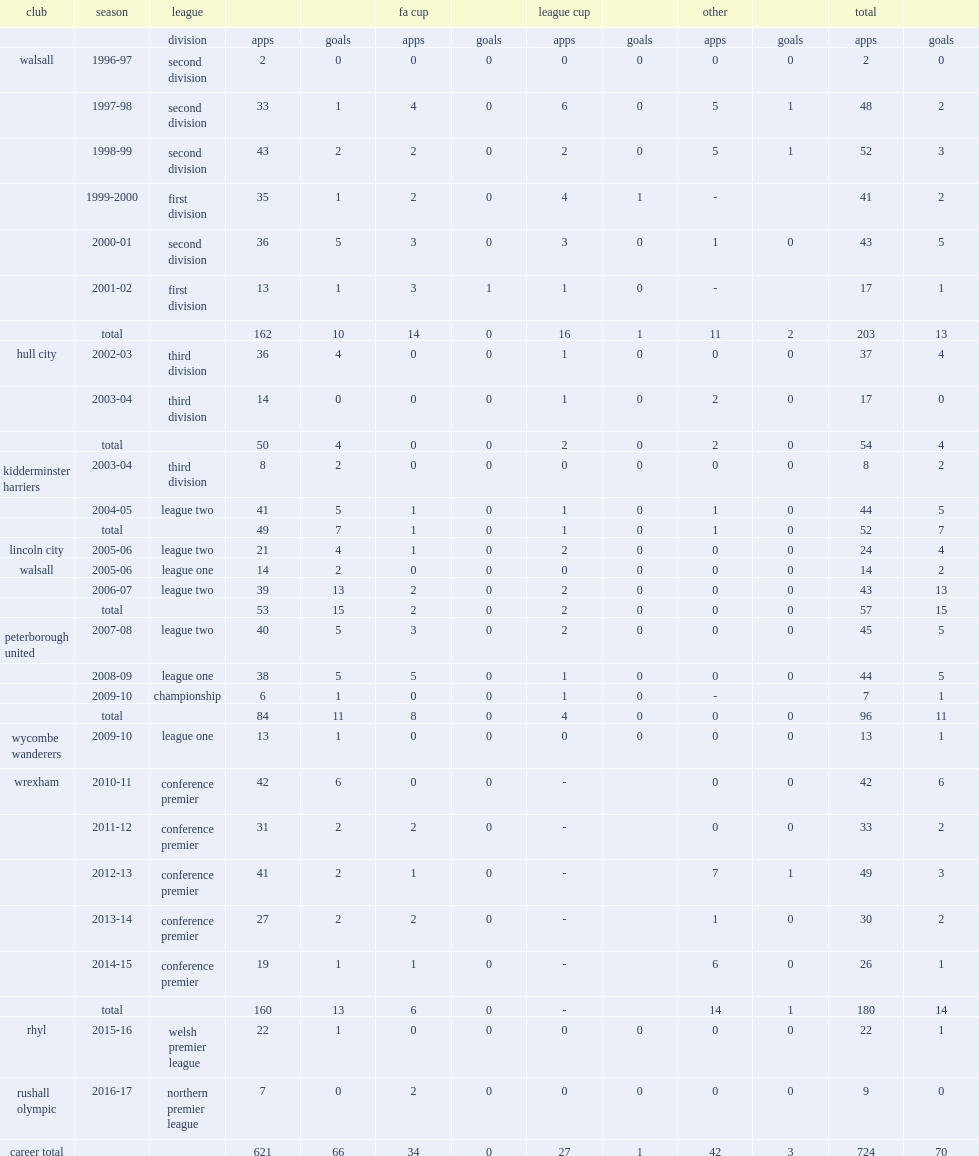Which club did keates play for in 2006-07? Walsall. 